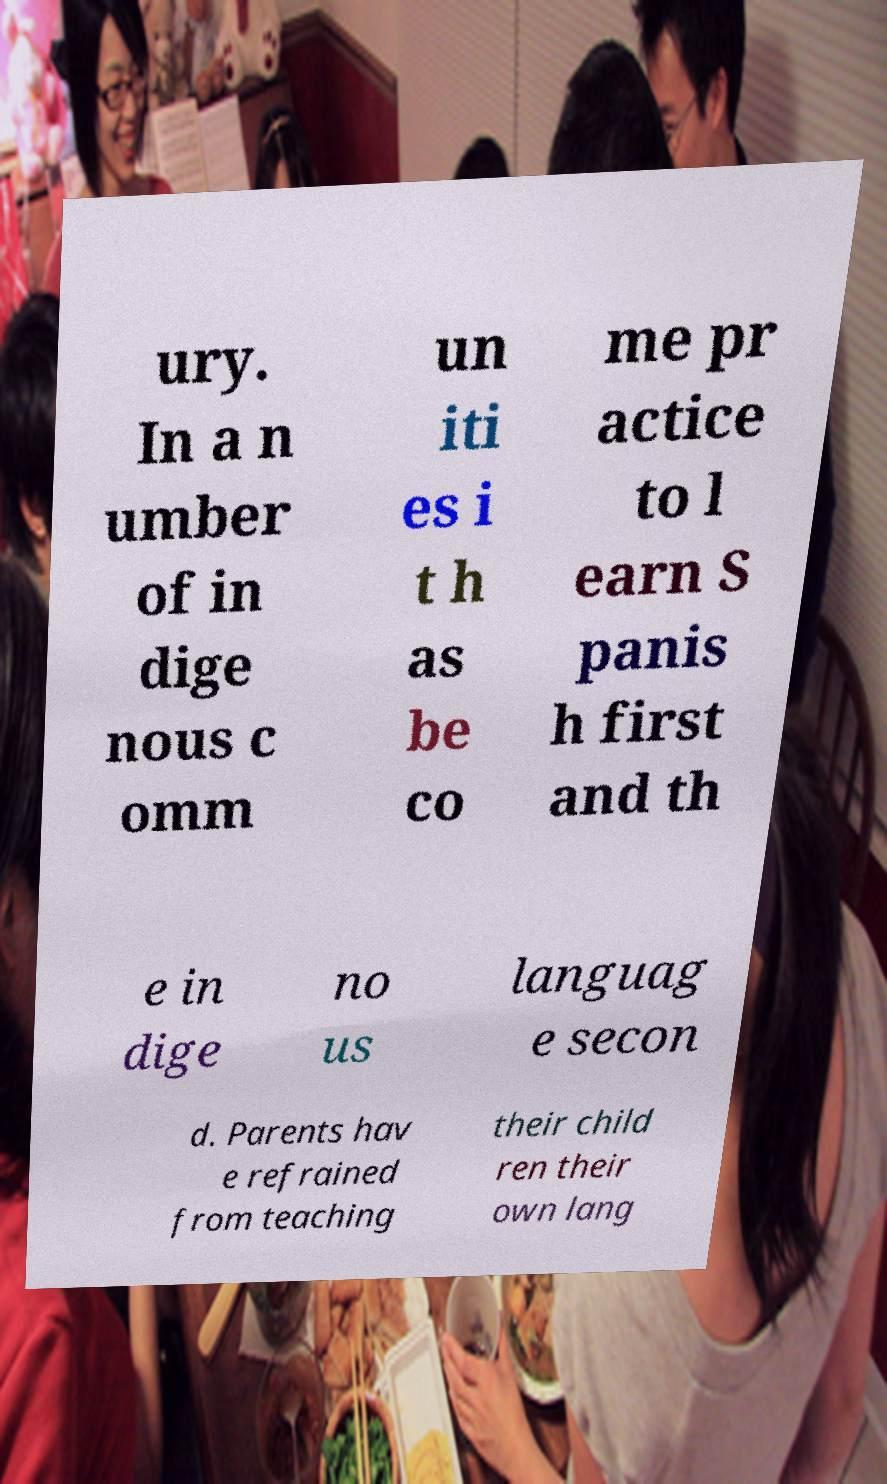For documentation purposes, I need the text within this image transcribed. Could you provide that? ury. In a n umber of in dige nous c omm un iti es i t h as be co me pr actice to l earn S panis h first and th e in dige no us languag e secon d. Parents hav e refrained from teaching their child ren their own lang 